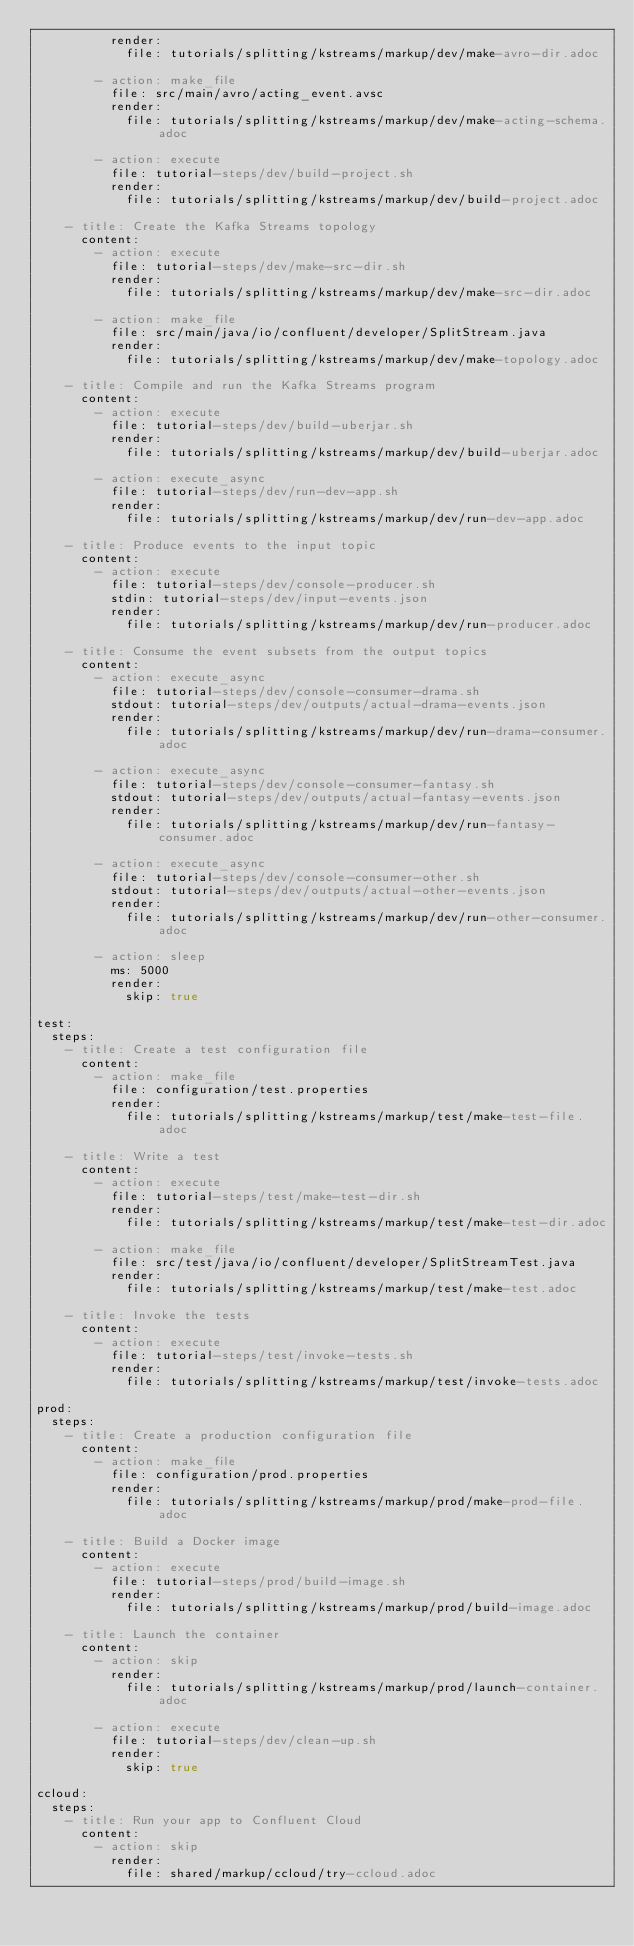Convert code to text. <code><loc_0><loc_0><loc_500><loc_500><_YAML_>          render:
            file: tutorials/splitting/kstreams/markup/dev/make-avro-dir.adoc

        - action: make_file
          file: src/main/avro/acting_event.avsc
          render:
            file: tutorials/splitting/kstreams/markup/dev/make-acting-schema.adoc

        - action: execute
          file: tutorial-steps/dev/build-project.sh
          render:
            file: tutorials/splitting/kstreams/markup/dev/build-project.adoc

    - title: Create the Kafka Streams topology
      content:
        - action: execute
          file: tutorial-steps/dev/make-src-dir.sh
          render:
            file: tutorials/splitting/kstreams/markup/dev/make-src-dir.adoc

        - action: make_file
          file: src/main/java/io/confluent/developer/SplitStream.java
          render:
            file: tutorials/splitting/kstreams/markup/dev/make-topology.adoc

    - title: Compile and run the Kafka Streams program
      content:
        - action: execute
          file: tutorial-steps/dev/build-uberjar.sh
          render:
            file: tutorials/splitting/kstreams/markup/dev/build-uberjar.adoc

        - action: execute_async
          file: tutorial-steps/dev/run-dev-app.sh
          render:
            file: tutorials/splitting/kstreams/markup/dev/run-dev-app.adoc

    - title: Produce events to the input topic
      content:
        - action: execute
          file: tutorial-steps/dev/console-producer.sh
          stdin: tutorial-steps/dev/input-events.json
          render:
            file: tutorials/splitting/kstreams/markup/dev/run-producer.adoc

    - title: Consume the event subsets from the output topics
      content:
        - action: execute_async
          file: tutorial-steps/dev/console-consumer-drama.sh
          stdout: tutorial-steps/dev/outputs/actual-drama-events.json
          render:
            file: tutorials/splitting/kstreams/markup/dev/run-drama-consumer.adoc

        - action: execute_async
          file: tutorial-steps/dev/console-consumer-fantasy.sh
          stdout: tutorial-steps/dev/outputs/actual-fantasy-events.json
          render:
            file: tutorials/splitting/kstreams/markup/dev/run-fantasy-consumer.adoc

        - action: execute_async
          file: tutorial-steps/dev/console-consumer-other.sh
          stdout: tutorial-steps/dev/outputs/actual-other-events.json
          render:
            file: tutorials/splitting/kstreams/markup/dev/run-other-consumer.adoc

        - action: sleep
          ms: 5000
          render:
            skip: true

test:
  steps:
    - title: Create a test configuration file
      content:
        - action: make_file
          file: configuration/test.properties
          render:
            file: tutorials/splitting/kstreams/markup/test/make-test-file.adoc

    - title: Write a test
      content:
        - action: execute
          file: tutorial-steps/test/make-test-dir.sh
          render:
            file: tutorials/splitting/kstreams/markup/test/make-test-dir.adoc

        - action: make_file
          file: src/test/java/io/confluent/developer/SplitStreamTest.java
          render:
            file: tutorials/splitting/kstreams/markup/test/make-test.adoc

    - title: Invoke the tests
      content:
        - action: execute
          file: tutorial-steps/test/invoke-tests.sh
          render:
            file: tutorials/splitting/kstreams/markup/test/invoke-tests.adoc

prod:
  steps:
    - title: Create a production configuration file
      content:
        - action: make_file
          file: configuration/prod.properties
          render:
            file: tutorials/splitting/kstreams/markup/prod/make-prod-file.adoc

    - title: Build a Docker image
      content:
        - action: execute
          file: tutorial-steps/prod/build-image.sh
          render:
            file: tutorials/splitting/kstreams/markup/prod/build-image.adoc

    - title: Launch the container
      content:
        - action: skip
          render:
            file: tutorials/splitting/kstreams/markup/prod/launch-container.adoc

        - action: execute
          file: tutorial-steps/dev/clean-up.sh
          render:
            skip: true            

ccloud:
  steps:
    - title: Run your app to Confluent Cloud
      content:
        - action: skip
          render:
            file: shared/markup/ccloud/try-ccloud.adoc
</code> 